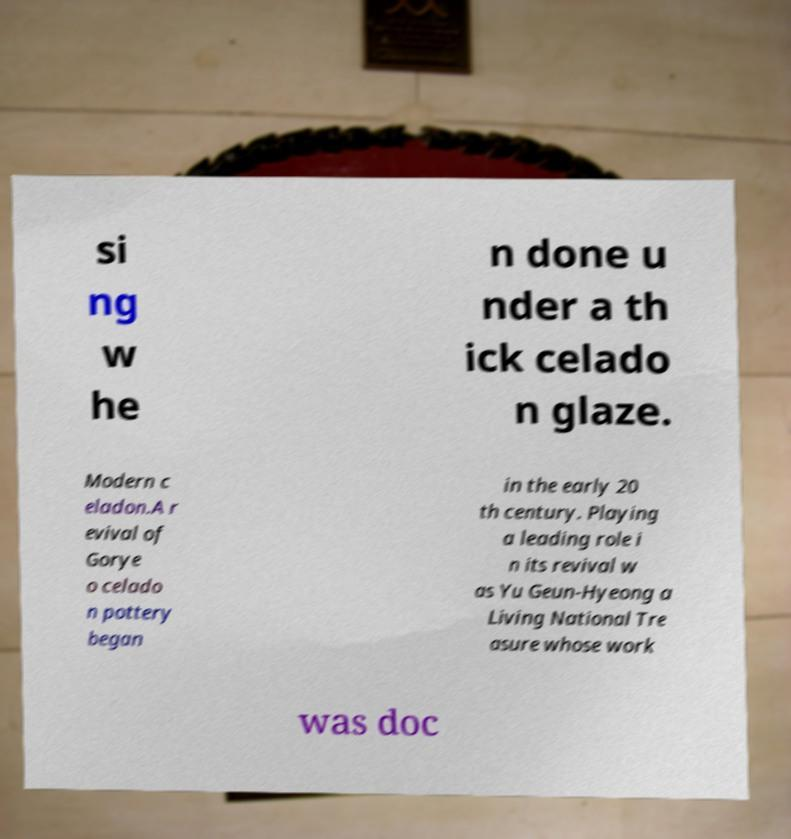Could you assist in decoding the text presented in this image and type it out clearly? si ng w he n done u nder a th ick celado n glaze. Modern c eladon.A r evival of Gorye o celado n pottery began in the early 20 th century. Playing a leading role i n its revival w as Yu Geun-Hyeong a Living National Tre asure whose work was doc 